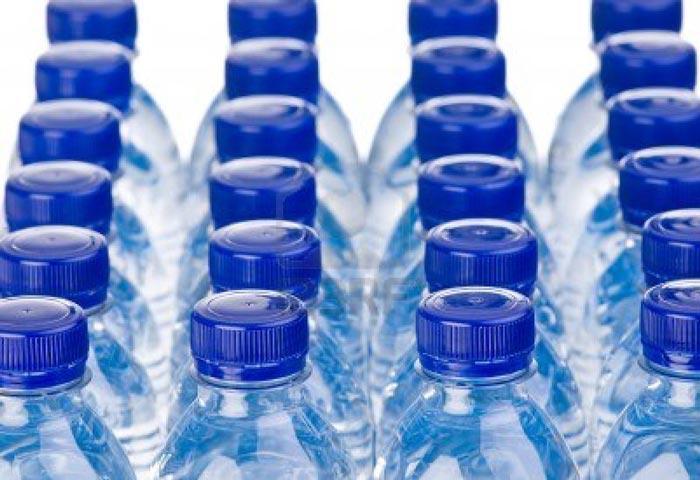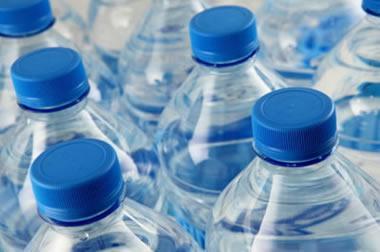The first image is the image on the left, the second image is the image on the right. For the images displayed, is the sentence "In 1 of the images, the bottles have large rectangular reflections." factually correct? Answer yes or no. No. 